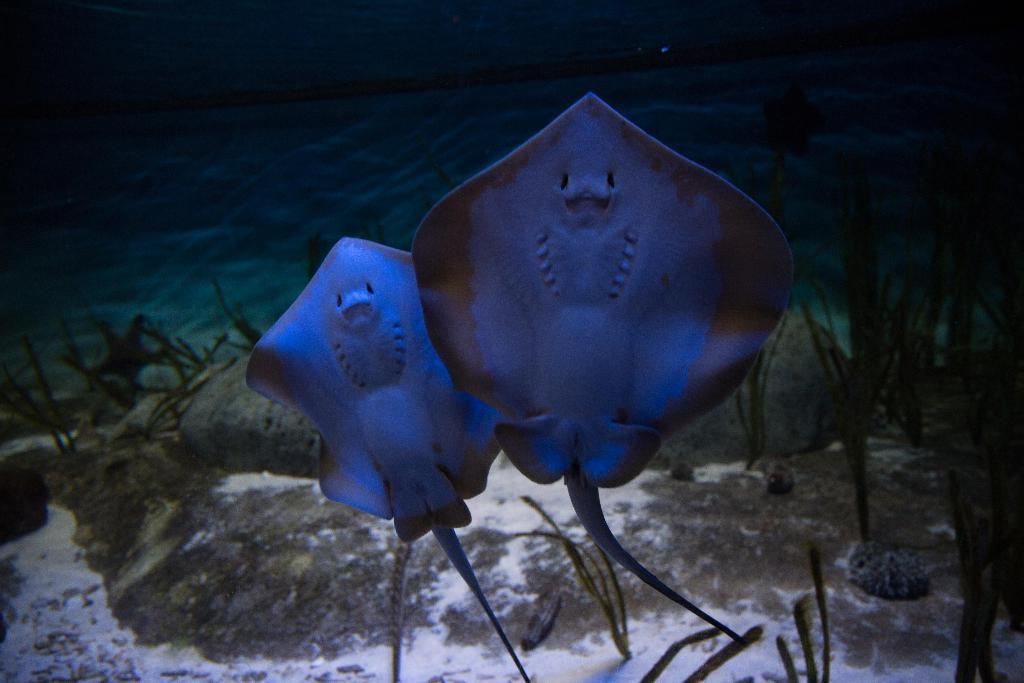What type of animals can be seen in the image? There are underwater animals in the image. What else can be found in the underwater environment depicted in the image? There are underwater plants in the image. What type of tomatoes can be seen growing on the mitten in the image? There is no mitten or tomatoes present in the image; it features underwater animals and plants. 